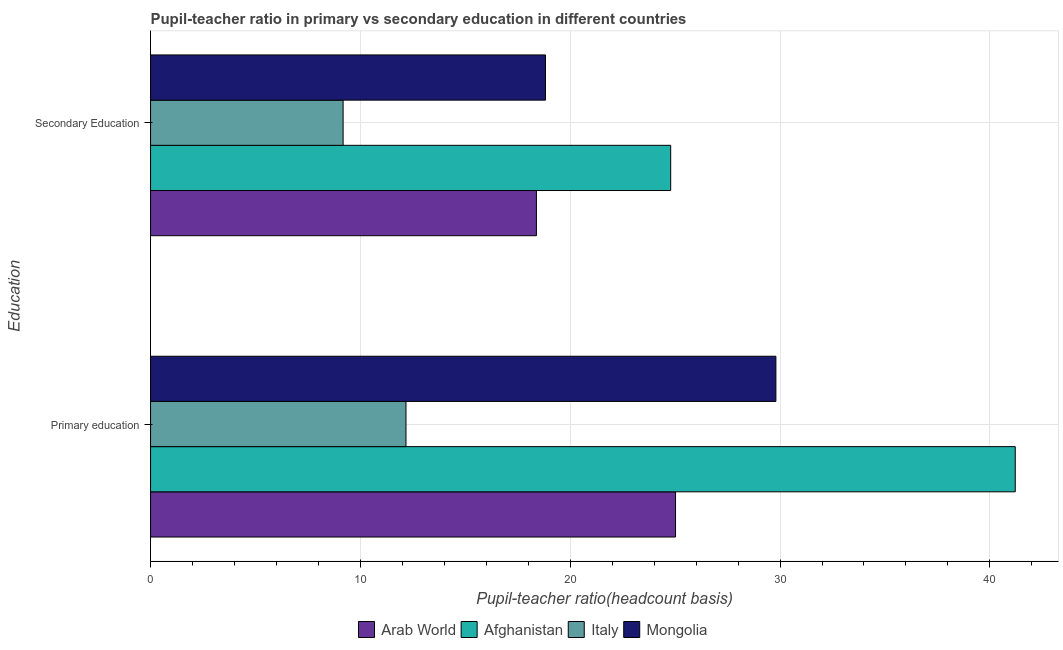Are the number of bars on each tick of the Y-axis equal?
Offer a terse response. Yes. What is the label of the 1st group of bars from the top?
Provide a succinct answer. Secondary Education. What is the pupil teacher ratio on secondary education in Italy?
Give a very brief answer. 9.18. Across all countries, what is the maximum pupil-teacher ratio in primary education?
Provide a succinct answer. 41.21. Across all countries, what is the minimum pupil teacher ratio on secondary education?
Your response must be concise. 9.18. In which country was the pupil teacher ratio on secondary education maximum?
Keep it short and to the point. Afghanistan. What is the total pupil teacher ratio on secondary education in the graph?
Offer a very short reply. 71.17. What is the difference between the pupil-teacher ratio in primary education in Italy and that in Afghanistan?
Your answer should be very brief. -29.04. What is the difference between the pupil teacher ratio on secondary education in Italy and the pupil-teacher ratio in primary education in Afghanistan?
Give a very brief answer. -32.03. What is the average pupil-teacher ratio in primary education per country?
Ensure brevity in your answer.  27.05. What is the difference between the pupil-teacher ratio in primary education and pupil teacher ratio on secondary education in Mongolia?
Make the answer very short. 10.98. What is the ratio of the pupil-teacher ratio in primary education in Afghanistan to that in Italy?
Ensure brevity in your answer.  3.39. Is the pupil teacher ratio on secondary education in Afghanistan less than that in Arab World?
Provide a short and direct response. No. What does the 3rd bar from the bottom in Primary education represents?
Give a very brief answer. Italy. How many countries are there in the graph?
Provide a succinct answer. 4. What is the difference between two consecutive major ticks on the X-axis?
Make the answer very short. 10. Does the graph contain grids?
Your answer should be compact. Yes. How many legend labels are there?
Offer a terse response. 4. How are the legend labels stacked?
Offer a very short reply. Horizontal. What is the title of the graph?
Give a very brief answer. Pupil-teacher ratio in primary vs secondary education in different countries. Does "Timor-Leste" appear as one of the legend labels in the graph?
Make the answer very short. No. What is the label or title of the X-axis?
Your answer should be compact. Pupil-teacher ratio(headcount basis). What is the label or title of the Y-axis?
Give a very brief answer. Education. What is the Pupil-teacher ratio(headcount basis) of Arab World in Primary education?
Ensure brevity in your answer.  25.02. What is the Pupil-teacher ratio(headcount basis) in Afghanistan in Primary education?
Your answer should be very brief. 41.21. What is the Pupil-teacher ratio(headcount basis) in Italy in Primary education?
Offer a very short reply. 12.17. What is the Pupil-teacher ratio(headcount basis) of Mongolia in Primary education?
Make the answer very short. 29.8. What is the Pupil-teacher ratio(headcount basis) in Arab World in Secondary Education?
Your answer should be compact. 18.39. What is the Pupil-teacher ratio(headcount basis) in Afghanistan in Secondary Education?
Your answer should be very brief. 24.79. What is the Pupil-teacher ratio(headcount basis) in Italy in Secondary Education?
Your answer should be compact. 9.18. What is the Pupil-teacher ratio(headcount basis) of Mongolia in Secondary Education?
Your answer should be very brief. 18.82. Across all Education, what is the maximum Pupil-teacher ratio(headcount basis) of Arab World?
Offer a very short reply. 25.02. Across all Education, what is the maximum Pupil-teacher ratio(headcount basis) of Afghanistan?
Provide a short and direct response. 41.21. Across all Education, what is the maximum Pupil-teacher ratio(headcount basis) in Italy?
Provide a short and direct response. 12.17. Across all Education, what is the maximum Pupil-teacher ratio(headcount basis) in Mongolia?
Keep it short and to the point. 29.8. Across all Education, what is the minimum Pupil-teacher ratio(headcount basis) in Arab World?
Ensure brevity in your answer.  18.39. Across all Education, what is the minimum Pupil-teacher ratio(headcount basis) in Afghanistan?
Offer a very short reply. 24.79. Across all Education, what is the minimum Pupil-teacher ratio(headcount basis) of Italy?
Offer a terse response. 9.18. Across all Education, what is the minimum Pupil-teacher ratio(headcount basis) of Mongolia?
Your answer should be compact. 18.82. What is the total Pupil-teacher ratio(headcount basis) in Arab World in the graph?
Your answer should be very brief. 43.41. What is the total Pupil-teacher ratio(headcount basis) of Afghanistan in the graph?
Your answer should be compact. 66. What is the total Pupil-teacher ratio(headcount basis) in Italy in the graph?
Make the answer very short. 21.35. What is the total Pupil-teacher ratio(headcount basis) of Mongolia in the graph?
Make the answer very short. 48.62. What is the difference between the Pupil-teacher ratio(headcount basis) in Arab World in Primary education and that in Secondary Education?
Offer a very short reply. 6.63. What is the difference between the Pupil-teacher ratio(headcount basis) in Afghanistan in Primary education and that in Secondary Education?
Your response must be concise. 16.42. What is the difference between the Pupil-teacher ratio(headcount basis) of Italy in Primary education and that in Secondary Education?
Give a very brief answer. 3. What is the difference between the Pupil-teacher ratio(headcount basis) in Mongolia in Primary education and that in Secondary Education?
Make the answer very short. 10.98. What is the difference between the Pupil-teacher ratio(headcount basis) of Arab World in Primary education and the Pupil-teacher ratio(headcount basis) of Afghanistan in Secondary Education?
Offer a very short reply. 0.23. What is the difference between the Pupil-teacher ratio(headcount basis) of Arab World in Primary education and the Pupil-teacher ratio(headcount basis) of Italy in Secondary Education?
Offer a very short reply. 15.84. What is the difference between the Pupil-teacher ratio(headcount basis) in Arab World in Primary education and the Pupil-teacher ratio(headcount basis) in Mongolia in Secondary Education?
Provide a succinct answer. 6.2. What is the difference between the Pupil-teacher ratio(headcount basis) of Afghanistan in Primary education and the Pupil-teacher ratio(headcount basis) of Italy in Secondary Education?
Provide a short and direct response. 32.03. What is the difference between the Pupil-teacher ratio(headcount basis) of Afghanistan in Primary education and the Pupil-teacher ratio(headcount basis) of Mongolia in Secondary Education?
Your answer should be compact. 22.39. What is the difference between the Pupil-teacher ratio(headcount basis) in Italy in Primary education and the Pupil-teacher ratio(headcount basis) in Mongolia in Secondary Education?
Make the answer very short. -6.65. What is the average Pupil-teacher ratio(headcount basis) in Arab World per Education?
Provide a succinct answer. 21.7. What is the average Pupil-teacher ratio(headcount basis) of Afghanistan per Education?
Offer a very short reply. 33. What is the average Pupil-teacher ratio(headcount basis) in Italy per Education?
Your response must be concise. 10.67. What is the average Pupil-teacher ratio(headcount basis) of Mongolia per Education?
Keep it short and to the point. 24.31. What is the difference between the Pupil-teacher ratio(headcount basis) in Arab World and Pupil-teacher ratio(headcount basis) in Afghanistan in Primary education?
Keep it short and to the point. -16.19. What is the difference between the Pupil-teacher ratio(headcount basis) in Arab World and Pupil-teacher ratio(headcount basis) in Italy in Primary education?
Your answer should be very brief. 12.85. What is the difference between the Pupil-teacher ratio(headcount basis) of Arab World and Pupil-teacher ratio(headcount basis) of Mongolia in Primary education?
Provide a short and direct response. -4.78. What is the difference between the Pupil-teacher ratio(headcount basis) of Afghanistan and Pupil-teacher ratio(headcount basis) of Italy in Primary education?
Keep it short and to the point. 29.04. What is the difference between the Pupil-teacher ratio(headcount basis) of Afghanistan and Pupil-teacher ratio(headcount basis) of Mongolia in Primary education?
Offer a terse response. 11.41. What is the difference between the Pupil-teacher ratio(headcount basis) of Italy and Pupil-teacher ratio(headcount basis) of Mongolia in Primary education?
Your response must be concise. -17.63. What is the difference between the Pupil-teacher ratio(headcount basis) in Arab World and Pupil-teacher ratio(headcount basis) in Afghanistan in Secondary Education?
Keep it short and to the point. -6.4. What is the difference between the Pupil-teacher ratio(headcount basis) in Arab World and Pupil-teacher ratio(headcount basis) in Italy in Secondary Education?
Ensure brevity in your answer.  9.21. What is the difference between the Pupil-teacher ratio(headcount basis) in Arab World and Pupil-teacher ratio(headcount basis) in Mongolia in Secondary Education?
Your response must be concise. -0.43. What is the difference between the Pupil-teacher ratio(headcount basis) of Afghanistan and Pupil-teacher ratio(headcount basis) of Italy in Secondary Education?
Your answer should be compact. 15.61. What is the difference between the Pupil-teacher ratio(headcount basis) of Afghanistan and Pupil-teacher ratio(headcount basis) of Mongolia in Secondary Education?
Your response must be concise. 5.97. What is the difference between the Pupil-teacher ratio(headcount basis) in Italy and Pupil-teacher ratio(headcount basis) in Mongolia in Secondary Education?
Make the answer very short. -9.65. What is the ratio of the Pupil-teacher ratio(headcount basis) of Arab World in Primary education to that in Secondary Education?
Offer a terse response. 1.36. What is the ratio of the Pupil-teacher ratio(headcount basis) of Afghanistan in Primary education to that in Secondary Education?
Keep it short and to the point. 1.66. What is the ratio of the Pupil-teacher ratio(headcount basis) in Italy in Primary education to that in Secondary Education?
Offer a very short reply. 1.33. What is the ratio of the Pupil-teacher ratio(headcount basis) of Mongolia in Primary education to that in Secondary Education?
Your answer should be compact. 1.58. What is the difference between the highest and the second highest Pupil-teacher ratio(headcount basis) of Arab World?
Provide a short and direct response. 6.63. What is the difference between the highest and the second highest Pupil-teacher ratio(headcount basis) of Afghanistan?
Keep it short and to the point. 16.42. What is the difference between the highest and the second highest Pupil-teacher ratio(headcount basis) of Italy?
Offer a very short reply. 3. What is the difference between the highest and the second highest Pupil-teacher ratio(headcount basis) of Mongolia?
Offer a very short reply. 10.98. What is the difference between the highest and the lowest Pupil-teacher ratio(headcount basis) in Arab World?
Keep it short and to the point. 6.63. What is the difference between the highest and the lowest Pupil-teacher ratio(headcount basis) in Afghanistan?
Your response must be concise. 16.42. What is the difference between the highest and the lowest Pupil-teacher ratio(headcount basis) in Italy?
Give a very brief answer. 3. What is the difference between the highest and the lowest Pupil-teacher ratio(headcount basis) in Mongolia?
Your answer should be very brief. 10.98. 